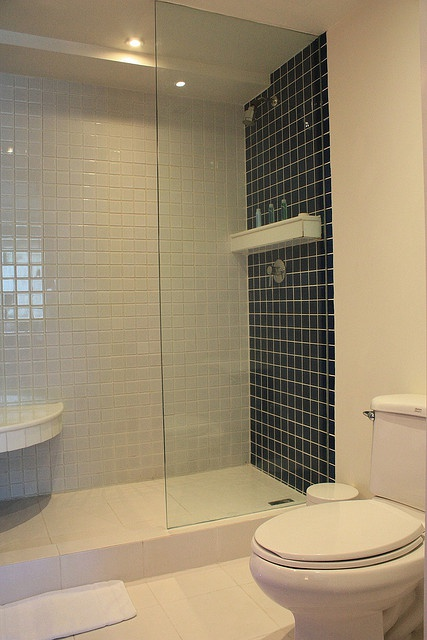Describe the objects in this image and their specific colors. I can see a toilet in gray and tan tones in this image. 